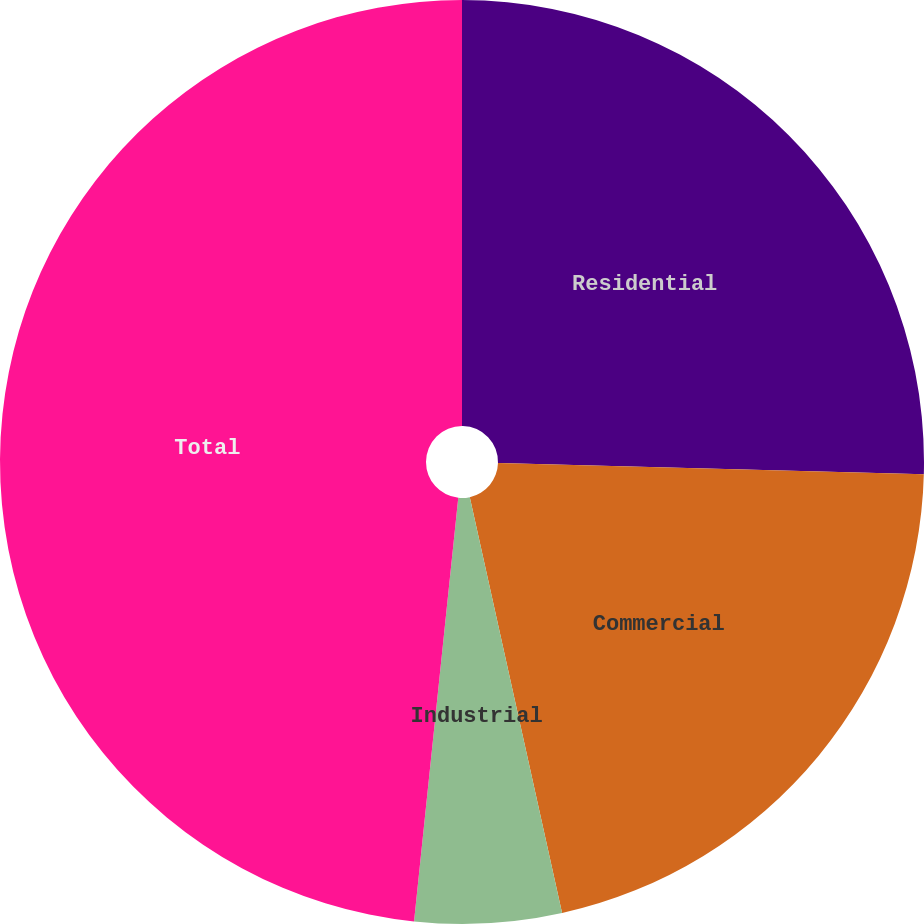Convert chart. <chart><loc_0><loc_0><loc_500><loc_500><pie_chart><fcel>Residential<fcel>Commercial<fcel>Industrial<fcel>Total<nl><fcel>25.42%<fcel>21.1%<fcel>5.13%<fcel>48.34%<nl></chart> 